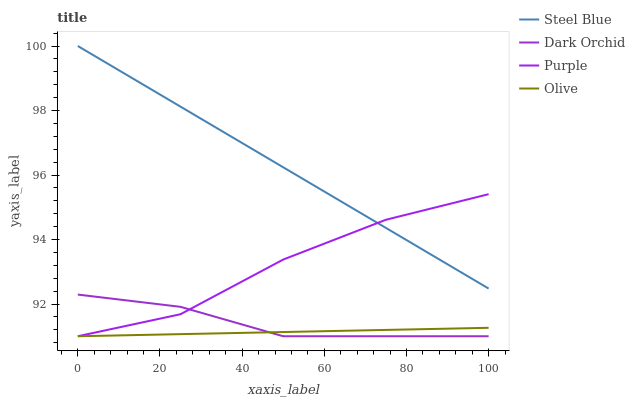Does Olive have the minimum area under the curve?
Answer yes or no. Yes. Does Steel Blue have the maximum area under the curve?
Answer yes or no. Yes. Does Steel Blue have the minimum area under the curve?
Answer yes or no. No. Does Olive have the maximum area under the curve?
Answer yes or no. No. Is Olive the smoothest?
Answer yes or no. Yes. Is Purple the roughest?
Answer yes or no. Yes. Is Steel Blue the smoothest?
Answer yes or no. No. Is Steel Blue the roughest?
Answer yes or no. No. Does Purple have the lowest value?
Answer yes or no. Yes. Does Steel Blue have the lowest value?
Answer yes or no. No. Does Steel Blue have the highest value?
Answer yes or no. Yes. Does Olive have the highest value?
Answer yes or no. No. Is Olive less than Steel Blue?
Answer yes or no. Yes. Is Steel Blue greater than Olive?
Answer yes or no. Yes. Does Purple intersect Dark Orchid?
Answer yes or no. Yes. Is Purple less than Dark Orchid?
Answer yes or no. No. Is Purple greater than Dark Orchid?
Answer yes or no. No. Does Olive intersect Steel Blue?
Answer yes or no. No. 